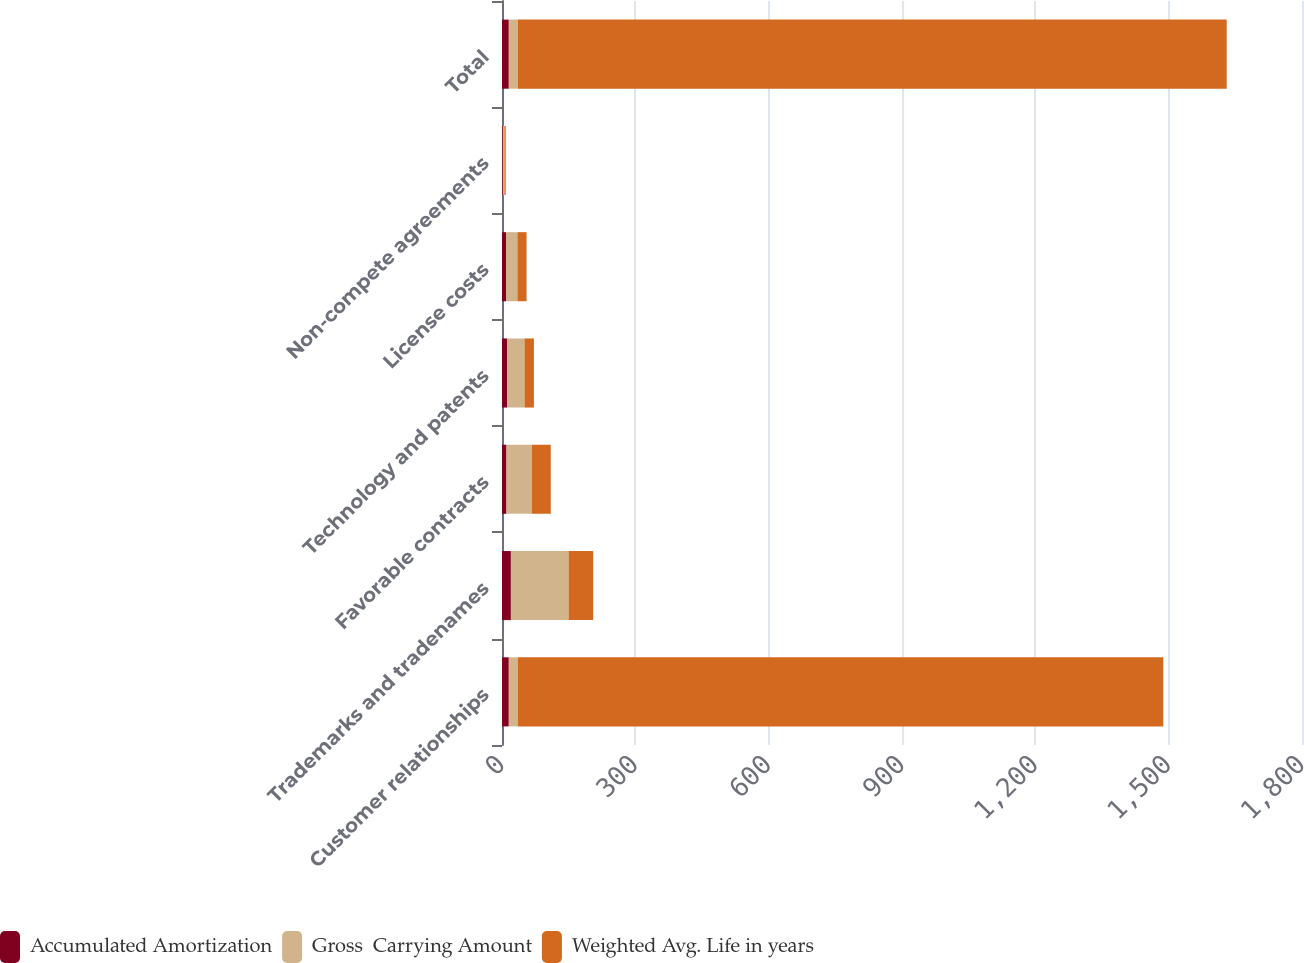Convert chart. <chart><loc_0><loc_0><loc_500><loc_500><stacked_bar_chart><ecel><fcel>Customer relationships<fcel>Trademarks and tradenames<fcel>Favorable contracts<fcel>Technology and patents<fcel>License costs<fcel>Non-compete agreements<fcel>Total<nl><fcel>Accumulated Amortization<fcel>15.3<fcel>20<fcel>10.1<fcel>11.4<fcel>9<fcel>2<fcel>15.3<nl><fcel>Gross  Carrying Amount<fcel>20.5<fcel>129.9<fcel>57<fcel>39.2<fcel>25.7<fcel>3.4<fcel>20.5<nl><fcel>Weighted Avg. Life in years<fcel>1452.1<fcel>55.3<fcel>42.6<fcel>21.2<fcel>20.5<fcel>2.9<fcel>1594.8<nl></chart> 